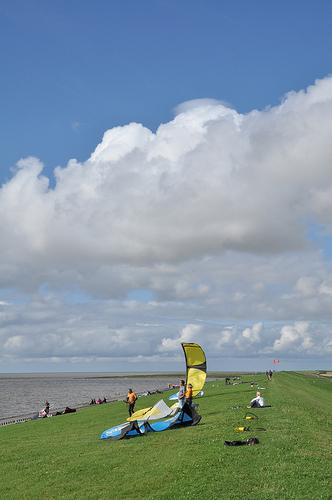Question: where is the scene?
Choices:
A. At the beach.
B. In the sand.
C. On the lake shoreline.
D. On the dune.
Answer with the letter. Answer: C Question: who is sitting on the grassy hill?
Choices:
A. A girl.
B. A person in a white shirt.
C. A boy.
D. A man.
Answer with the letter. Answer: B 